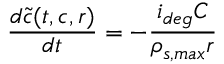<formula> <loc_0><loc_0><loc_500><loc_500>\frac { d \tilde { c } ( t , c , r ) } { d t } = - \frac { i _ { d e g } C } { \rho _ { s , \max } r }</formula> 